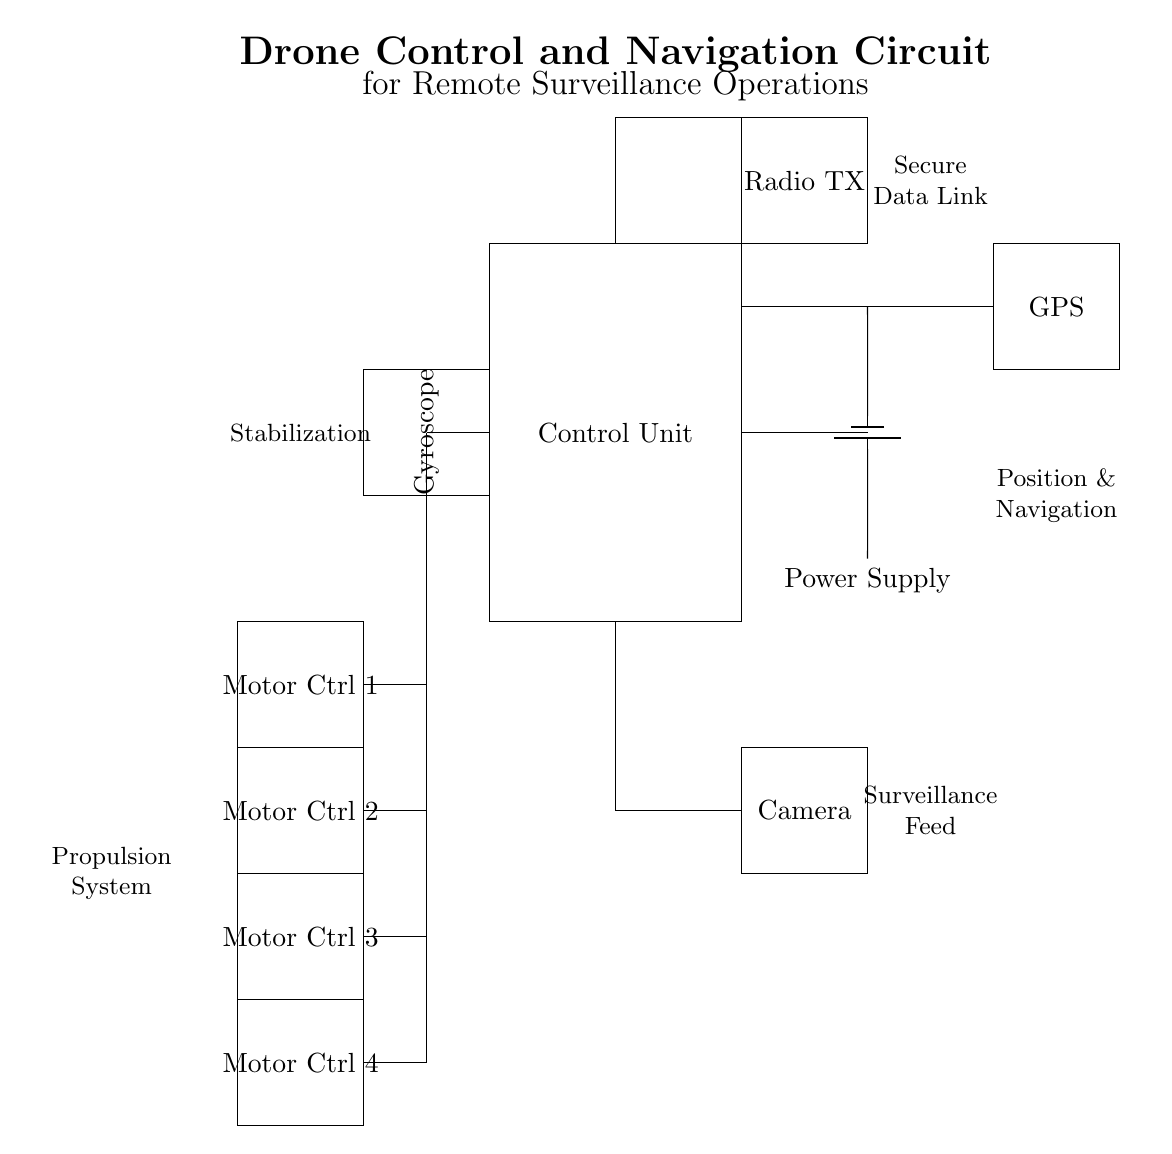What is the main function of the Control Unit? The Control Unit processes commands and controls the operation of all connected components, including navigation and surveillance tasks.
Answer: Command processing What type of components are used for propulsion control? The diagram shows four Motor Controllers specifically designed to manage the drone's propulsion system.
Answer: Motor Controllers How is the drone's position determined? The GPS module is responsible for determining the drone's position and navigation data essential for flight operations.
Answer: GPS module What is the purpose of the Radio Transmitter in this circuit? The Radio Transmitter is used to send telemetry and commands to the drone, supporting remote communication and control.
Answer: Remote communication Which component provides the surveillance feed? The Camera module captures video footage and is responsible for the surveillance feed sent back to the operator.
Answer: Camera module How many motor controllers are present in the circuit? The circuit includes four motor controllers, indicating the capacity to manage four individual motors for thrust and maneuverability.
Answer: Four What connection links the Control Unit to the Power Supply? The connection is a direct line that supplies electrical power to the Control Unit, allowing it to function and manage other components.
Answer: Power connection 